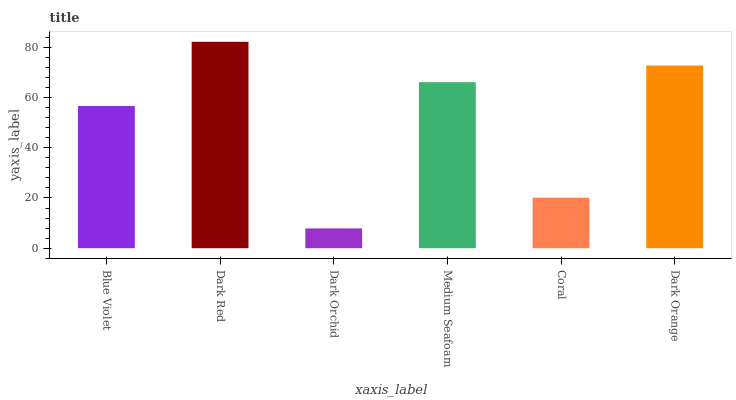Is Dark Orchid the minimum?
Answer yes or no. Yes. Is Dark Red the maximum?
Answer yes or no. Yes. Is Dark Red the minimum?
Answer yes or no. No. Is Dark Orchid the maximum?
Answer yes or no. No. Is Dark Red greater than Dark Orchid?
Answer yes or no. Yes. Is Dark Orchid less than Dark Red?
Answer yes or no. Yes. Is Dark Orchid greater than Dark Red?
Answer yes or no. No. Is Dark Red less than Dark Orchid?
Answer yes or no. No. Is Medium Seafoam the high median?
Answer yes or no. Yes. Is Blue Violet the low median?
Answer yes or no. Yes. Is Coral the high median?
Answer yes or no. No. Is Dark Red the low median?
Answer yes or no. No. 